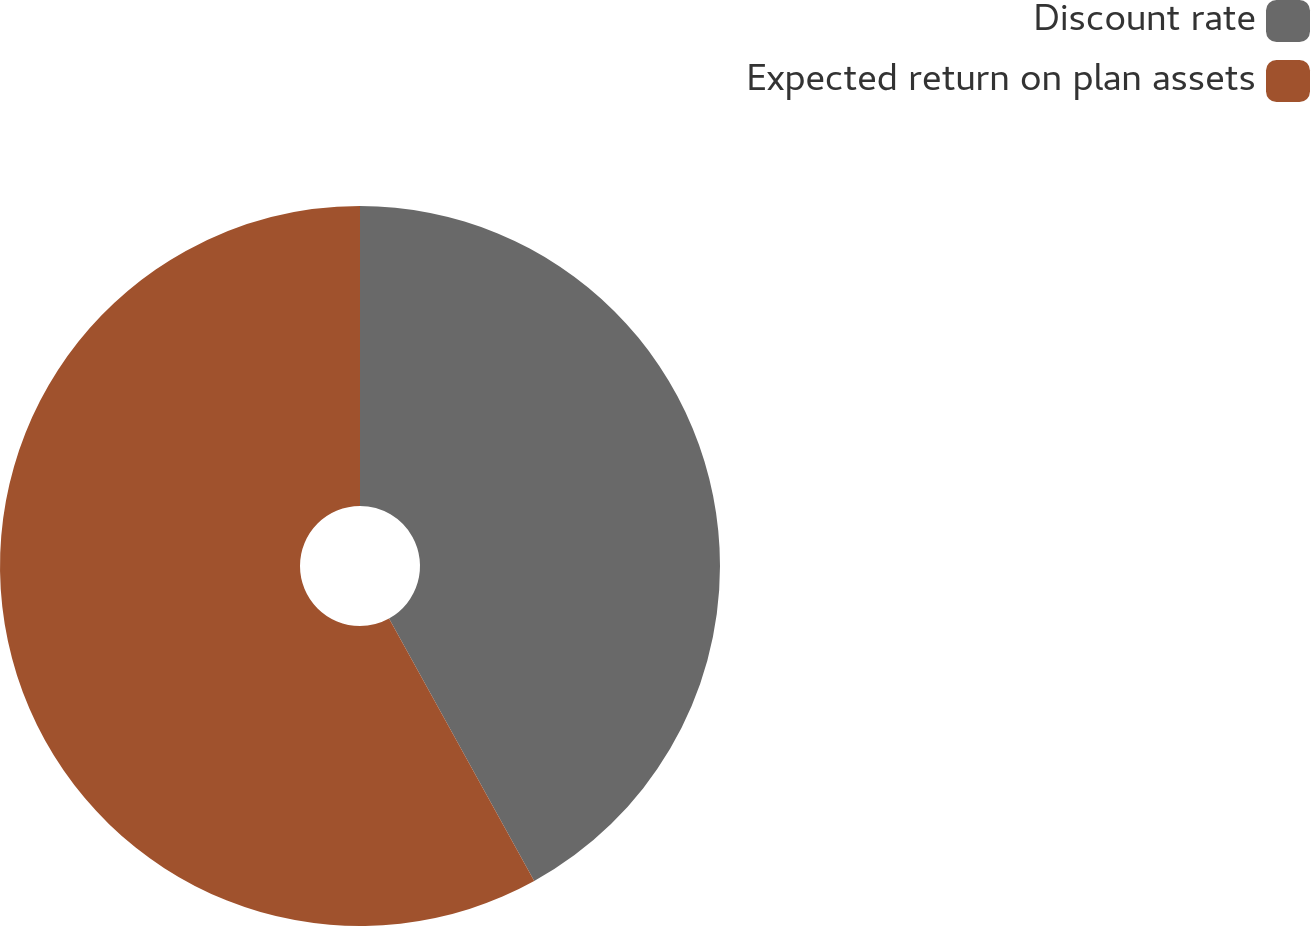Convert chart. <chart><loc_0><loc_0><loc_500><loc_500><pie_chart><fcel>Discount rate<fcel>Expected return on plan assets<nl><fcel>41.96%<fcel>58.04%<nl></chart> 